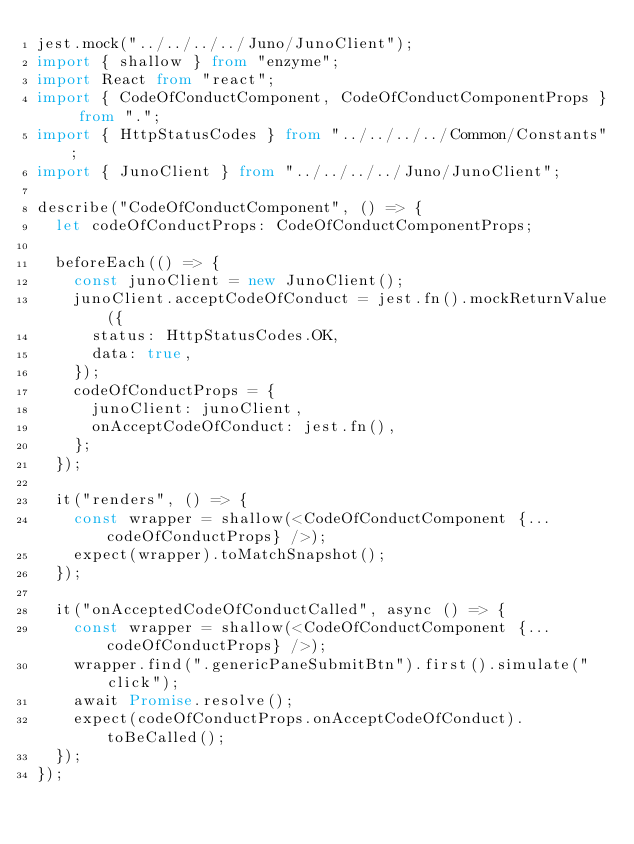<code> <loc_0><loc_0><loc_500><loc_500><_TypeScript_>jest.mock("../../../../Juno/JunoClient");
import { shallow } from "enzyme";
import React from "react";
import { CodeOfConductComponent, CodeOfConductComponentProps } from ".";
import { HttpStatusCodes } from "../../../../Common/Constants";
import { JunoClient } from "../../../../Juno/JunoClient";

describe("CodeOfConductComponent", () => {
  let codeOfConductProps: CodeOfConductComponentProps;

  beforeEach(() => {
    const junoClient = new JunoClient();
    junoClient.acceptCodeOfConduct = jest.fn().mockReturnValue({
      status: HttpStatusCodes.OK,
      data: true,
    });
    codeOfConductProps = {
      junoClient: junoClient,
      onAcceptCodeOfConduct: jest.fn(),
    };
  });

  it("renders", () => {
    const wrapper = shallow(<CodeOfConductComponent {...codeOfConductProps} />);
    expect(wrapper).toMatchSnapshot();
  });

  it("onAcceptedCodeOfConductCalled", async () => {
    const wrapper = shallow(<CodeOfConductComponent {...codeOfConductProps} />);
    wrapper.find(".genericPaneSubmitBtn").first().simulate("click");
    await Promise.resolve();
    expect(codeOfConductProps.onAcceptCodeOfConduct).toBeCalled();
  });
});
</code> 